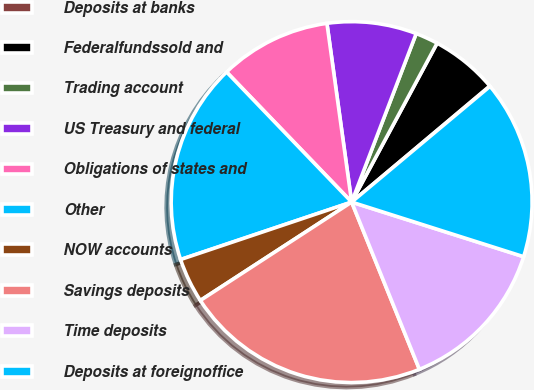Convert chart to OTSL. <chart><loc_0><loc_0><loc_500><loc_500><pie_chart><fcel>Deposits at banks<fcel>Federalfundssold and<fcel>Trading account<fcel>US Treasury and federal<fcel>Obligations of states and<fcel>Other<fcel>NOW accounts<fcel>Savings deposits<fcel>Time deposits<fcel>Deposits at foreignoffice<nl><fcel>0.04%<fcel>6.02%<fcel>2.03%<fcel>8.01%<fcel>10.0%<fcel>17.97%<fcel>4.02%<fcel>21.95%<fcel>13.98%<fcel>15.98%<nl></chart> 